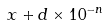Convert formula to latex. <formula><loc_0><loc_0><loc_500><loc_500>x + d \times 1 0 ^ { - n }</formula> 